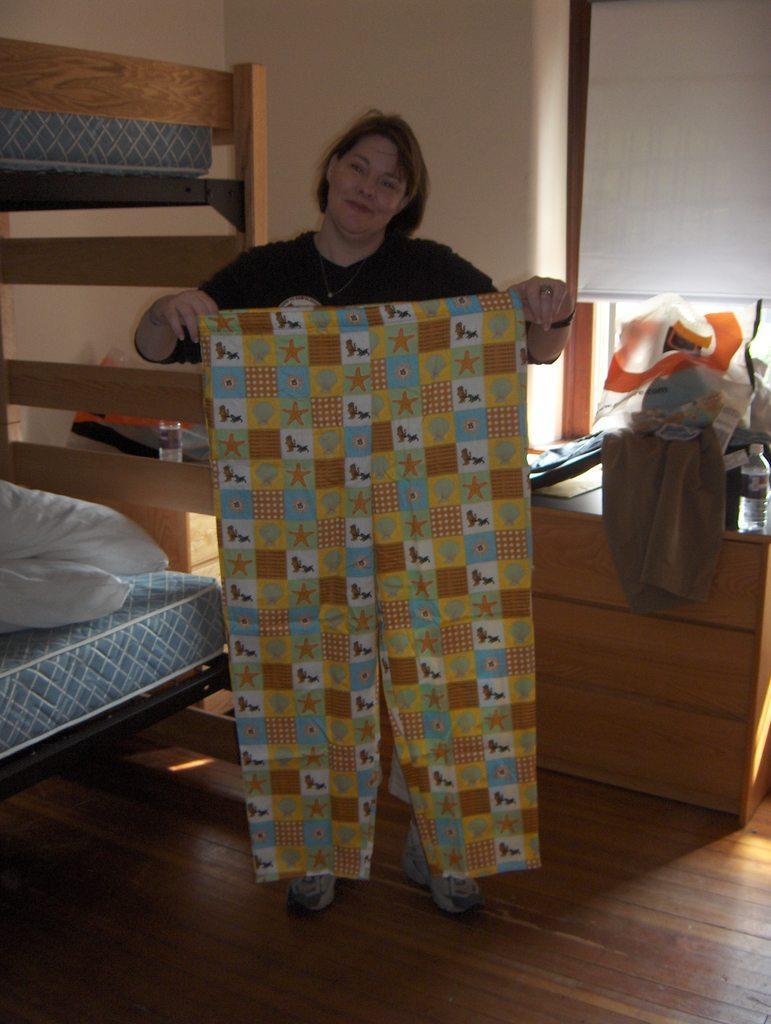Could you give a brief overview of what you see in this image? In this image we can see a woman wearing black T-shirt is holding a pant in her hands and standing on the wooden floor. Here we can see the bed with pillows, wooden drawers on which we can see a few things kept, window blinds and the wall in the background. 